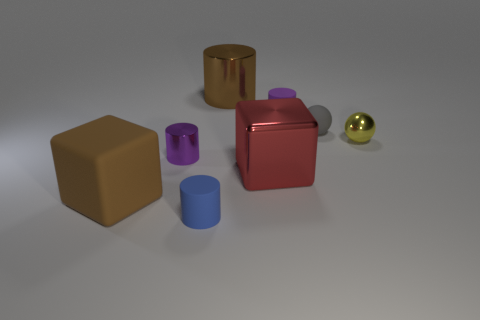What is the blue cylinder in front of the purple rubber thing made of?
Your answer should be very brief. Rubber. What color is the big cylinder?
Your response must be concise. Brown. There is a purple cylinder that is on the left side of the brown shiny object; is its size the same as the small yellow sphere?
Make the answer very short. Yes. There is a tiny yellow ball that is in front of the brown object behind the matte cylinder on the right side of the brown cylinder; what is its material?
Give a very brief answer. Metal. There is a object that is in front of the large brown rubber cube; is its color the same as the object that is right of the rubber ball?
Make the answer very short. No. What material is the brown thing that is behind the sphere behind the yellow metallic sphere?
Provide a succinct answer. Metal. What color is the metal cylinder that is the same size as the red cube?
Provide a short and direct response. Brown. Does the purple matte object have the same shape as the large brown object behind the big brown rubber cube?
Your response must be concise. Yes. There is a shiny object that is the same color as the big rubber block; what shape is it?
Give a very brief answer. Cylinder. There is a shiny cylinder in front of the small metallic thing to the right of the big metal cylinder; what number of metal objects are to the right of it?
Provide a short and direct response. 3. 